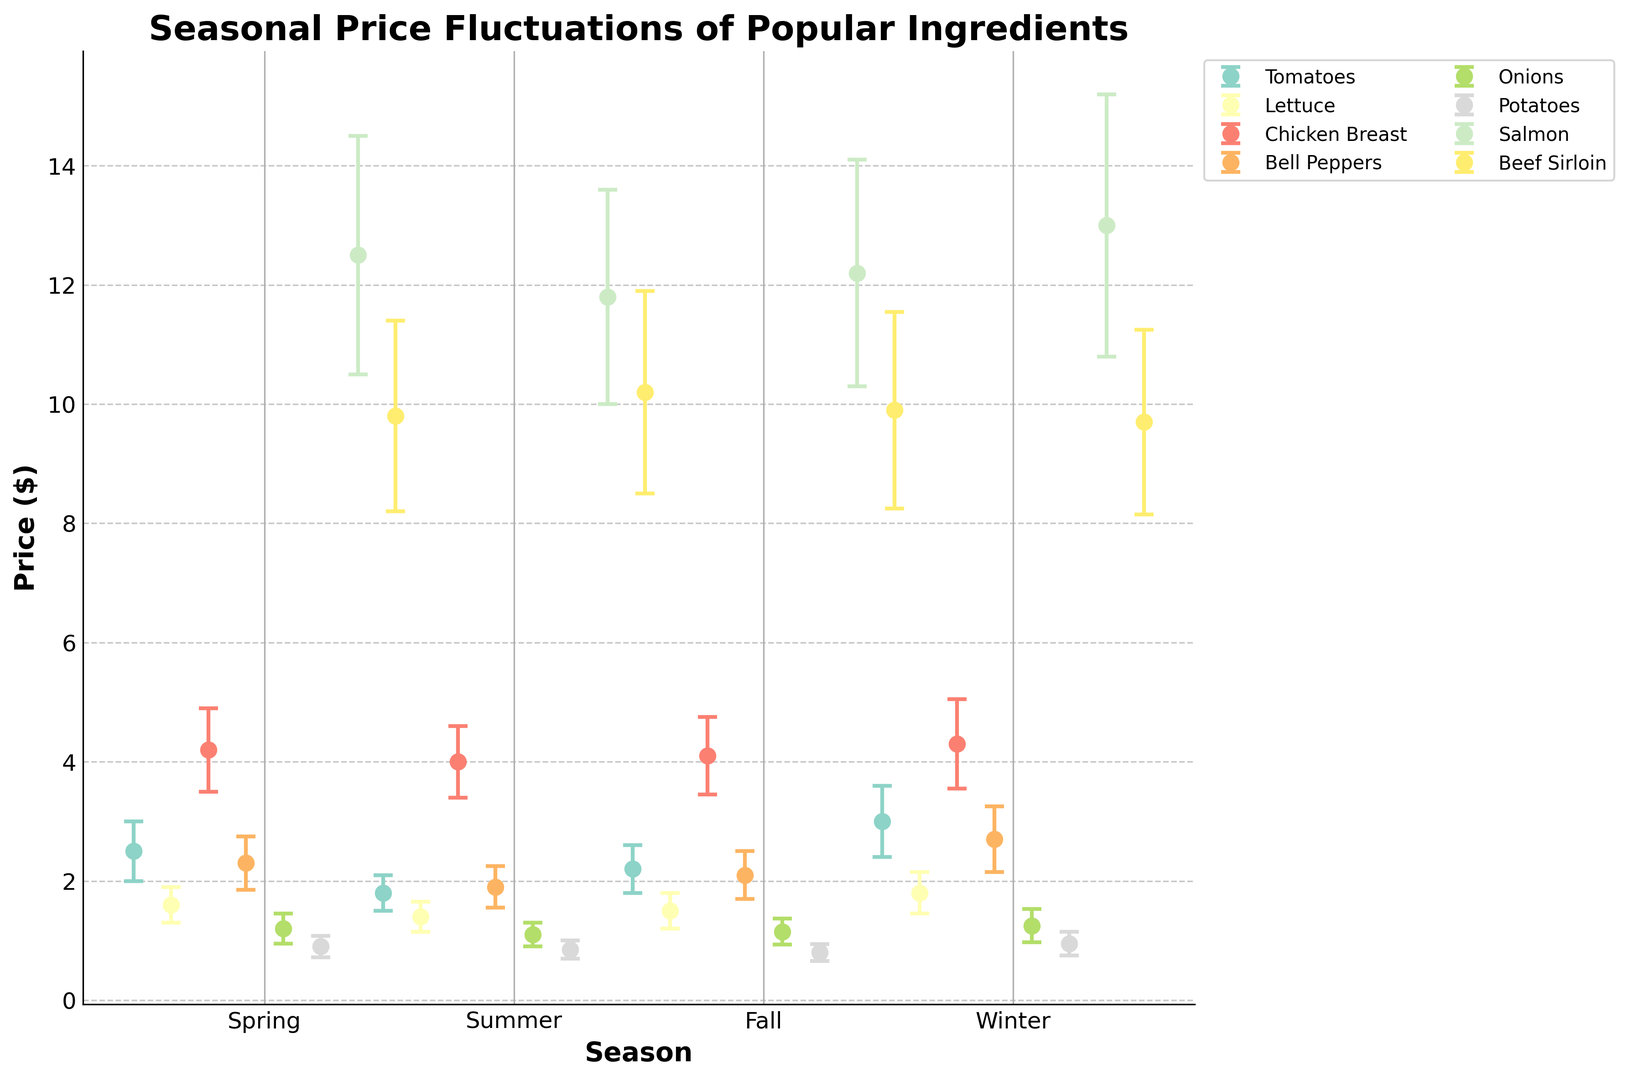What season has the highest average price for tomatoes? By looking at the plot for tomatoes, identify the highest point among the seasonal markers. The highest average price for tomatoes is in the winter.
Answer: Winter How does the price range of Bell Peppers in Summer compare to the price range in Winter? Compare the lengths of the error bars for Bell Peppers in Summer and Winter. The error bar in Winter is noticeably longer, indicating a wider price range.
Answer: Winter has a wider price range Which ingredient has the smallest price fluctuation in Fall? Look at the error bars in Fall for each ingredient and find the one with the shortest error bar. Onions have the smallest price range in Fall.
Answer: Onions What is the difference in average price for Salmon between Summer and Winter? Locate the average price markers for Salmon in both Summer and Winter, then subtract the Summer value from the Winter value. Winter ($13.00) minus Summer ($11.80) equals $1.20.
Answer: $1.20 Among Beef Sirloin across all seasons, which season has the highest average price? Identify the highest point among the seasonal markers for Beef Sirloin. Summer has the highest average price.
Answer: Summer Is the average price of Lettuce in Winter higher or lower than in Spring? Compare the height of the markers for Lettuce in Winter and Spring. The Winter marker is slightly higher than the Spring marker.
Answer: Higher For Chicken Breast, what is the total price range across all seasons? Sum up the price range across all seasons for Chicken Breast using their error values. The total is 0.70 (Spring) + 0.60 (Summer) + 0.65 (Fall) + 0.75 (Winter) equals 2.70.
Answer: 2.70 What visual feature indicates the average price of an ingredient in a given season? The average price is indicated by the central point of each vertical bar representing an ingredient's seasonal price.
Answer: Central point of vertical bar In which season is the price difference between Bell Peppers and Onions the greatest? Calculate the price differences between Bell Peppers and Onions in each season and identify the greatest value. In Winter, the price difference is the largest ($2.70 - $1.25 = $1.45).
Answer: Winter 